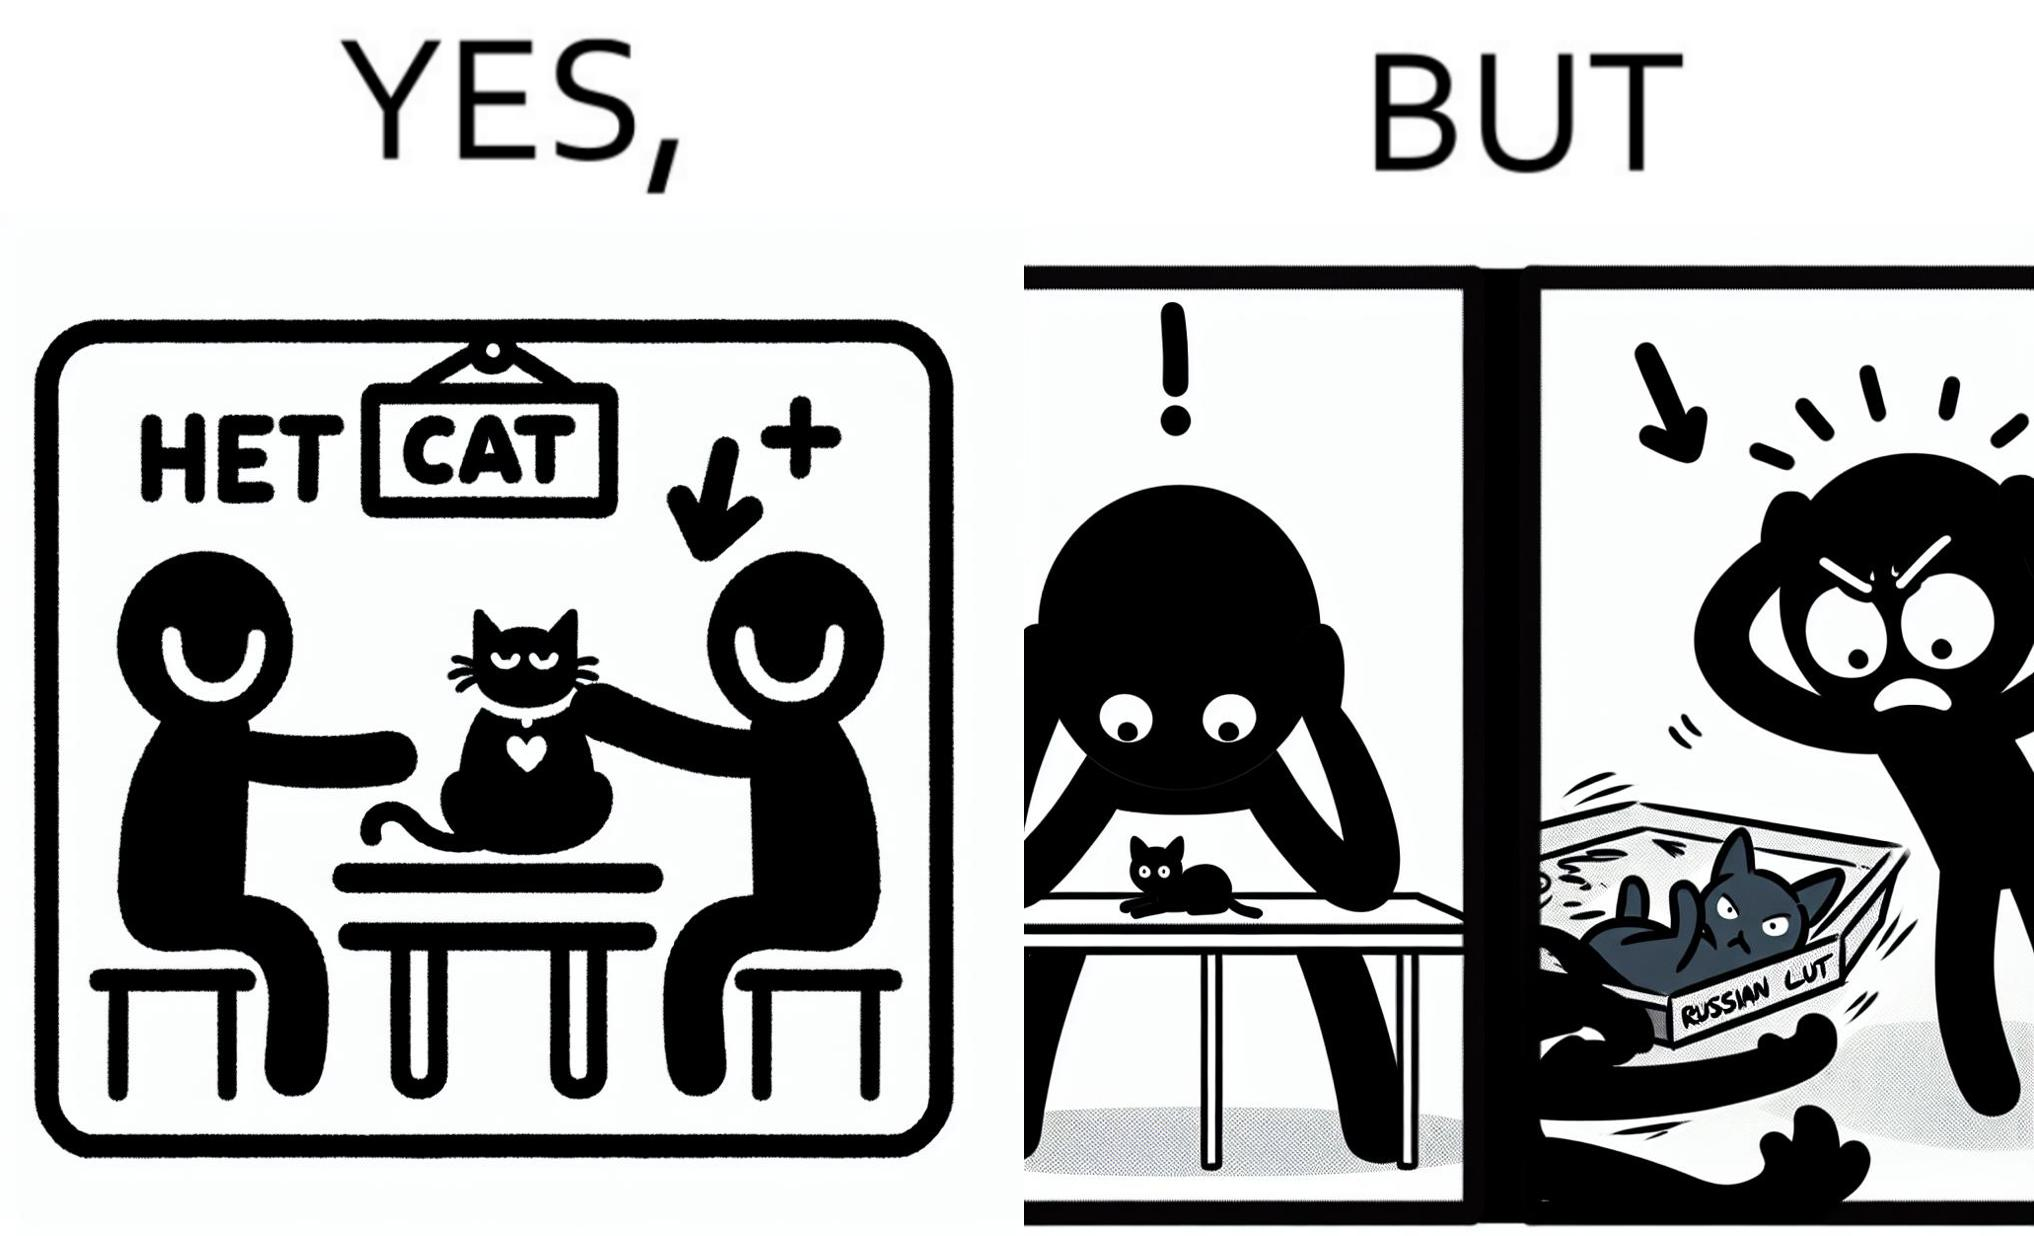Describe what you see in the left and right parts of this image. In the left part of the image: two happy people, where one of them is petting a cat sitting on a table, with a label "Blue Cat" written on the tabel. In the right part of the image: a worried person with hands on her head looking at a table with the label "Russian Blue Cat", while another angry person seems to be throwing away a cat. 